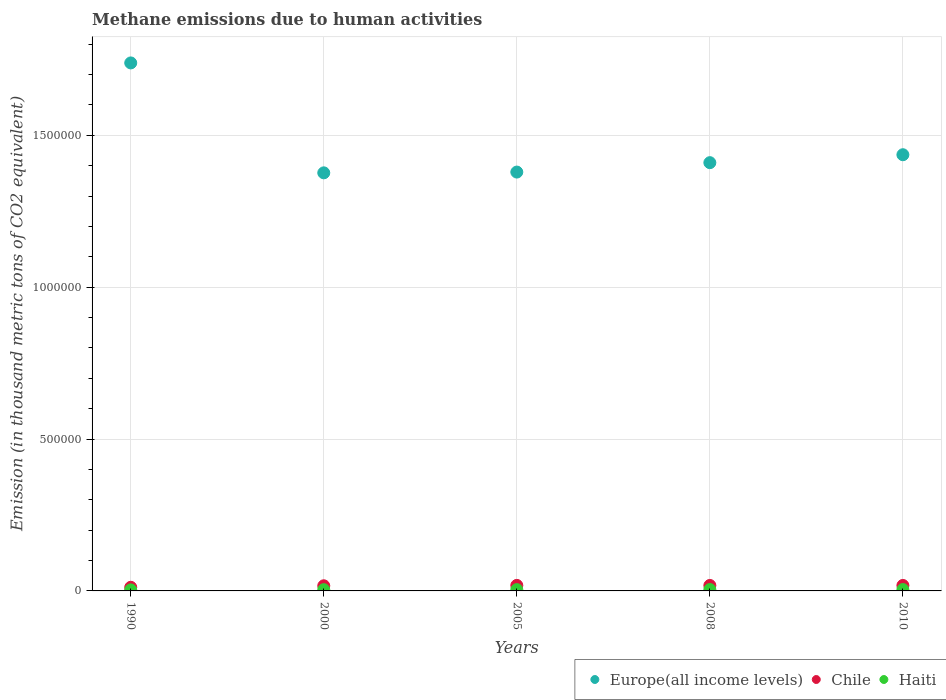Is the number of dotlines equal to the number of legend labels?
Your answer should be compact. Yes. What is the amount of methane emitted in Chile in 2010?
Give a very brief answer. 1.80e+04. Across all years, what is the maximum amount of methane emitted in Haiti?
Provide a short and direct response. 4497.3. Across all years, what is the minimum amount of methane emitted in Europe(all income levels)?
Provide a succinct answer. 1.38e+06. In which year was the amount of methane emitted in Europe(all income levels) minimum?
Provide a succinct answer. 2000. What is the total amount of methane emitted in Haiti in the graph?
Make the answer very short. 2.07e+04. What is the difference between the amount of methane emitted in Haiti in 2000 and that in 2005?
Give a very brief answer. -122.8. What is the difference between the amount of methane emitted in Haiti in 1990 and the amount of methane emitted in Chile in 2000?
Provide a succinct answer. -1.36e+04. What is the average amount of methane emitted in Chile per year?
Your response must be concise. 1.66e+04. In the year 2000, what is the difference between the amount of methane emitted in Chile and amount of methane emitted in Europe(all income levels)?
Offer a very short reply. -1.36e+06. What is the ratio of the amount of methane emitted in Haiti in 2008 to that in 2010?
Your answer should be very brief. 1. What is the difference between the highest and the second highest amount of methane emitted in Chile?
Offer a very short reply. 188.4. What is the difference between the highest and the lowest amount of methane emitted in Chile?
Your response must be concise. 6211.6. In how many years, is the amount of methane emitted in Chile greater than the average amount of methane emitted in Chile taken over all years?
Provide a succinct answer. 4. Is the sum of the amount of methane emitted in Europe(all income levels) in 1990 and 2010 greater than the maximum amount of methane emitted in Chile across all years?
Provide a succinct answer. Yes. Is it the case that in every year, the sum of the amount of methane emitted in Haiti and amount of methane emitted in Europe(all income levels)  is greater than the amount of methane emitted in Chile?
Keep it short and to the point. Yes. Is the amount of methane emitted in Chile strictly less than the amount of methane emitted in Europe(all income levels) over the years?
Your answer should be very brief. Yes. How many dotlines are there?
Keep it short and to the point. 3. What is the difference between two consecutive major ticks on the Y-axis?
Ensure brevity in your answer.  5.00e+05. Are the values on the major ticks of Y-axis written in scientific E-notation?
Make the answer very short. No. Does the graph contain any zero values?
Your answer should be very brief. No. Does the graph contain grids?
Provide a short and direct response. Yes. What is the title of the graph?
Ensure brevity in your answer.  Methane emissions due to human activities. Does "Somalia" appear as one of the legend labels in the graph?
Provide a succinct answer. No. What is the label or title of the Y-axis?
Offer a terse response. Emission (in thousand metric tons of CO2 equivalent). What is the Emission (in thousand metric tons of CO2 equivalent) of Europe(all income levels) in 1990?
Offer a terse response. 1.74e+06. What is the Emission (in thousand metric tons of CO2 equivalent) in Chile in 1990?
Offer a very short reply. 1.20e+04. What is the Emission (in thousand metric tons of CO2 equivalent) in Haiti in 1990?
Make the answer very short. 3307.8. What is the Emission (in thousand metric tons of CO2 equivalent) of Europe(all income levels) in 2000?
Your response must be concise. 1.38e+06. What is the Emission (in thousand metric tons of CO2 equivalent) of Chile in 2000?
Ensure brevity in your answer.  1.69e+04. What is the Emission (in thousand metric tons of CO2 equivalent) in Haiti in 2000?
Your answer should be very brief. 4132.6. What is the Emission (in thousand metric tons of CO2 equivalent) of Europe(all income levels) in 2005?
Make the answer very short. 1.38e+06. What is the Emission (in thousand metric tons of CO2 equivalent) of Chile in 2005?
Make the answer very short. 1.82e+04. What is the Emission (in thousand metric tons of CO2 equivalent) in Haiti in 2005?
Offer a very short reply. 4255.4. What is the Emission (in thousand metric tons of CO2 equivalent) of Europe(all income levels) in 2008?
Make the answer very short. 1.41e+06. What is the Emission (in thousand metric tons of CO2 equivalent) of Chile in 2008?
Offer a very short reply. 1.80e+04. What is the Emission (in thousand metric tons of CO2 equivalent) in Haiti in 2008?
Your response must be concise. 4492.1. What is the Emission (in thousand metric tons of CO2 equivalent) in Europe(all income levels) in 2010?
Ensure brevity in your answer.  1.44e+06. What is the Emission (in thousand metric tons of CO2 equivalent) in Chile in 2010?
Your answer should be compact. 1.80e+04. What is the Emission (in thousand metric tons of CO2 equivalent) of Haiti in 2010?
Offer a very short reply. 4497.3. Across all years, what is the maximum Emission (in thousand metric tons of CO2 equivalent) in Europe(all income levels)?
Keep it short and to the point. 1.74e+06. Across all years, what is the maximum Emission (in thousand metric tons of CO2 equivalent) of Chile?
Your response must be concise. 1.82e+04. Across all years, what is the maximum Emission (in thousand metric tons of CO2 equivalent) in Haiti?
Provide a short and direct response. 4497.3. Across all years, what is the minimum Emission (in thousand metric tons of CO2 equivalent) of Europe(all income levels)?
Give a very brief answer. 1.38e+06. Across all years, what is the minimum Emission (in thousand metric tons of CO2 equivalent) of Chile?
Offer a terse response. 1.20e+04. Across all years, what is the minimum Emission (in thousand metric tons of CO2 equivalent) in Haiti?
Ensure brevity in your answer.  3307.8. What is the total Emission (in thousand metric tons of CO2 equivalent) in Europe(all income levels) in the graph?
Your answer should be compact. 7.34e+06. What is the total Emission (in thousand metric tons of CO2 equivalent) in Chile in the graph?
Keep it short and to the point. 8.31e+04. What is the total Emission (in thousand metric tons of CO2 equivalent) of Haiti in the graph?
Your response must be concise. 2.07e+04. What is the difference between the Emission (in thousand metric tons of CO2 equivalent) in Europe(all income levels) in 1990 and that in 2000?
Offer a terse response. 3.62e+05. What is the difference between the Emission (in thousand metric tons of CO2 equivalent) of Chile in 1990 and that in 2000?
Keep it short and to the point. -4945.1. What is the difference between the Emission (in thousand metric tons of CO2 equivalent) of Haiti in 1990 and that in 2000?
Your response must be concise. -824.8. What is the difference between the Emission (in thousand metric tons of CO2 equivalent) of Europe(all income levels) in 1990 and that in 2005?
Provide a succinct answer. 3.59e+05. What is the difference between the Emission (in thousand metric tons of CO2 equivalent) of Chile in 1990 and that in 2005?
Your response must be concise. -6211.6. What is the difference between the Emission (in thousand metric tons of CO2 equivalent) in Haiti in 1990 and that in 2005?
Make the answer very short. -947.6. What is the difference between the Emission (in thousand metric tons of CO2 equivalent) of Europe(all income levels) in 1990 and that in 2008?
Your answer should be very brief. 3.28e+05. What is the difference between the Emission (in thousand metric tons of CO2 equivalent) in Chile in 1990 and that in 2008?
Keep it short and to the point. -6011.3. What is the difference between the Emission (in thousand metric tons of CO2 equivalent) in Haiti in 1990 and that in 2008?
Offer a terse response. -1184.3. What is the difference between the Emission (in thousand metric tons of CO2 equivalent) of Europe(all income levels) in 1990 and that in 2010?
Give a very brief answer. 3.02e+05. What is the difference between the Emission (in thousand metric tons of CO2 equivalent) in Chile in 1990 and that in 2010?
Your answer should be very brief. -6023.2. What is the difference between the Emission (in thousand metric tons of CO2 equivalent) in Haiti in 1990 and that in 2010?
Offer a very short reply. -1189.5. What is the difference between the Emission (in thousand metric tons of CO2 equivalent) in Europe(all income levels) in 2000 and that in 2005?
Offer a terse response. -2537.9. What is the difference between the Emission (in thousand metric tons of CO2 equivalent) of Chile in 2000 and that in 2005?
Your answer should be compact. -1266.5. What is the difference between the Emission (in thousand metric tons of CO2 equivalent) in Haiti in 2000 and that in 2005?
Your answer should be very brief. -122.8. What is the difference between the Emission (in thousand metric tons of CO2 equivalent) of Europe(all income levels) in 2000 and that in 2008?
Provide a succinct answer. -3.35e+04. What is the difference between the Emission (in thousand metric tons of CO2 equivalent) in Chile in 2000 and that in 2008?
Your answer should be compact. -1066.2. What is the difference between the Emission (in thousand metric tons of CO2 equivalent) of Haiti in 2000 and that in 2008?
Provide a short and direct response. -359.5. What is the difference between the Emission (in thousand metric tons of CO2 equivalent) of Europe(all income levels) in 2000 and that in 2010?
Offer a terse response. -5.96e+04. What is the difference between the Emission (in thousand metric tons of CO2 equivalent) in Chile in 2000 and that in 2010?
Offer a very short reply. -1078.1. What is the difference between the Emission (in thousand metric tons of CO2 equivalent) of Haiti in 2000 and that in 2010?
Your answer should be very brief. -364.7. What is the difference between the Emission (in thousand metric tons of CO2 equivalent) of Europe(all income levels) in 2005 and that in 2008?
Keep it short and to the point. -3.10e+04. What is the difference between the Emission (in thousand metric tons of CO2 equivalent) in Chile in 2005 and that in 2008?
Offer a very short reply. 200.3. What is the difference between the Emission (in thousand metric tons of CO2 equivalent) in Haiti in 2005 and that in 2008?
Your response must be concise. -236.7. What is the difference between the Emission (in thousand metric tons of CO2 equivalent) of Europe(all income levels) in 2005 and that in 2010?
Give a very brief answer. -5.71e+04. What is the difference between the Emission (in thousand metric tons of CO2 equivalent) in Chile in 2005 and that in 2010?
Offer a very short reply. 188.4. What is the difference between the Emission (in thousand metric tons of CO2 equivalent) in Haiti in 2005 and that in 2010?
Offer a very short reply. -241.9. What is the difference between the Emission (in thousand metric tons of CO2 equivalent) in Europe(all income levels) in 2008 and that in 2010?
Ensure brevity in your answer.  -2.61e+04. What is the difference between the Emission (in thousand metric tons of CO2 equivalent) in Haiti in 2008 and that in 2010?
Offer a very short reply. -5.2. What is the difference between the Emission (in thousand metric tons of CO2 equivalent) in Europe(all income levels) in 1990 and the Emission (in thousand metric tons of CO2 equivalent) in Chile in 2000?
Offer a very short reply. 1.72e+06. What is the difference between the Emission (in thousand metric tons of CO2 equivalent) of Europe(all income levels) in 1990 and the Emission (in thousand metric tons of CO2 equivalent) of Haiti in 2000?
Your answer should be very brief. 1.73e+06. What is the difference between the Emission (in thousand metric tons of CO2 equivalent) of Chile in 1990 and the Emission (in thousand metric tons of CO2 equivalent) of Haiti in 2000?
Your answer should be compact. 7845.5. What is the difference between the Emission (in thousand metric tons of CO2 equivalent) in Europe(all income levels) in 1990 and the Emission (in thousand metric tons of CO2 equivalent) in Chile in 2005?
Offer a terse response. 1.72e+06. What is the difference between the Emission (in thousand metric tons of CO2 equivalent) of Europe(all income levels) in 1990 and the Emission (in thousand metric tons of CO2 equivalent) of Haiti in 2005?
Offer a very short reply. 1.73e+06. What is the difference between the Emission (in thousand metric tons of CO2 equivalent) in Chile in 1990 and the Emission (in thousand metric tons of CO2 equivalent) in Haiti in 2005?
Make the answer very short. 7722.7. What is the difference between the Emission (in thousand metric tons of CO2 equivalent) in Europe(all income levels) in 1990 and the Emission (in thousand metric tons of CO2 equivalent) in Chile in 2008?
Offer a terse response. 1.72e+06. What is the difference between the Emission (in thousand metric tons of CO2 equivalent) in Europe(all income levels) in 1990 and the Emission (in thousand metric tons of CO2 equivalent) in Haiti in 2008?
Ensure brevity in your answer.  1.73e+06. What is the difference between the Emission (in thousand metric tons of CO2 equivalent) of Chile in 1990 and the Emission (in thousand metric tons of CO2 equivalent) of Haiti in 2008?
Offer a very short reply. 7486. What is the difference between the Emission (in thousand metric tons of CO2 equivalent) of Europe(all income levels) in 1990 and the Emission (in thousand metric tons of CO2 equivalent) of Chile in 2010?
Provide a succinct answer. 1.72e+06. What is the difference between the Emission (in thousand metric tons of CO2 equivalent) in Europe(all income levels) in 1990 and the Emission (in thousand metric tons of CO2 equivalent) in Haiti in 2010?
Your answer should be compact. 1.73e+06. What is the difference between the Emission (in thousand metric tons of CO2 equivalent) of Chile in 1990 and the Emission (in thousand metric tons of CO2 equivalent) of Haiti in 2010?
Keep it short and to the point. 7480.8. What is the difference between the Emission (in thousand metric tons of CO2 equivalent) of Europe(all income levels) in 2000 and the Emission (in thousand metric tons of CO2 equivalent) of Chile in 2005?
Your answer should be compact. 1.36e+06. What is the difference between the Emission (in thousand metric tons of CO2 equivalent) of Europe(all income levels) in 2000 and the Emission (in thousand metric tons of CO2 equivalent) of Haiti in 2005?
Make the answer very short. 1.37e+06. What is the difference between the Emission (in thousand metric tons of CO2 equivalent) of Chile in 2000 and the Emission (in thousand metric tons of CO2 equivalent) of Haiti in 2005?
Your response must be concise. 1.27e+04. What is the difference between the Emission (in thousand metric tons of CO2 equivalent) in Europe(all income levels) in 2000 and the Emission (in thousand metric tons of CO2 equivalent) in Chile in 2008?
Ensure brevity in your answer.  1.36e+06. What is the difference between the Emission (in thousand metric tons of CO2 equivalent) in Europe(all income levels) in 2000 and the Emission (in thousand metric tons of CO2 equivalent) in Haiti in 2008?
Offer a very short reply. 1.37e+06. What is the difference between the Emission (in thousand metric tons of CO2 equivalent) in Chile in 2000 and the Emission (in thousand metric tons of CO2 equivalent) in Haiti in 2008?
Offer a terse response. 1.24e+04. What is the difference between the Emission (in thousand metric tons of CO2 equivalent) in Europe(all income levels) in 2000 and the Emission (in thousand metric tons of CO2 equivalent) in Chile in 2010?
Give a very brief answer. 1.36e+06. What is the difference between the Emission (in thousand metric tons of CO2 equivalent) of Europe(all income levels) in 2000 and the Emission (in thousand metric tons of CO2 equivalent) of Haiti in 2010?
Give a very brief answer. 1.37e+06. What is the difference between the Emission (in thousand metric tons of CO2 equivalent) in Chile in 2000 and the Emission (in thousand metric tons of CO2 equivalent) in Haiti in 2010?
Your answer should be compact. 1.24e+04. What is the difference between the Emission (in thousand metric tons of CO2 equivalent) of Europe(all income levels) in 2005 and the Emission (in thousand metric tons of CO2 equivalent) of Chile in 2008?
Make the answer very short. 1.36e+06. What is the difference between the Emission (in thousand metric tons of CO2 equivalent) of Europe(all income levels) in 2005 and the Emission (in thousand metric tons of CO2 equivalent) of Haiti in 2008?
Provide a succinct answer. 1.37e+06. What is the difference between the Emission (in thousand metric tons of CO2 equivalent) of Chile in 2005 and the Emission (in thousand metric tons of CO2 equivalent) of Haiti in 2008?
Your answer should be compact. 1.37e+04. What is the difference between the Emission (in thousand metric tons of CO2 equivalent) of Europe(all income levels) in 2005 and the Emission (in thousand metric tons of CO2 equivalent) of Chile in 2010?
Your answer should be very brief. 1.36e+06. What is the difference between the Emission (in thousand metric tons of CO2 equivalent) in Europe(all income levels) in 2005 and the Emission (in thousand metric tons of CO2 equivalent) in Haiti in 2010?
Ensure brevity in your answer.  1.37e+06. What is the difference between the Emission (in thousand metric tons of CO2 equivalent) of Chile in 2005 and the Emission (in thousand metric tons of CO2 equivalent) of Haiti in 2010?
Offer a very short reply. 1.37e+04. What is the difference between the Emission (in thousand metric tons of CO2 equivalent) of Europe(all income levels) in 2008 and the Emission (in thousand metric tons of CO2 equivalent) of Chile in 2010?
Ensure brevity in your answer.  1.39e+06. What is the difference between the Emission (in thousand metric tons of CO2 equivalent) in Europe(all income levels) in 2008 and the Emission (in thousand metric tons of CO2 equivalent) in Haiti in 2010?
Your answer should be compact. 1.41e+06. What is the difference between the Emission (in thousand metric tons of CO2 equivalent) in Chile in 2008 and the Emission (in thousand metric tons of CO2 equivalent) in Haiti in 2010?
Offer a terse response. 1.35e+04. What is the average Emission (in thousand metric tons of CO2 equivalent) in Europe(all income levels) per year?
Provide a short and direct response. 1.47e+06. What is the average Emission (in thousand metric tons of CO2 equivalent) of Chile per year?
Make the answer very short. 1.66e+04. What is the average Emission (in thousand metric tons of CO2 equivalent) of Haiti per year?
Make the answer very short. 4137.04. In the year 1990, what is the difference between the Emission (in thousand metric tons of CO2 equivalent) in Europe(all income levels) and Emission (in thousand metric tons of CO2 equivalent) in Chile?
Provide a succinct answer. 1.73e+06. In the year 1990, what is the difference between the Emission (in thousand metric tons of CO2 equivalent) in Europe(all income levels) and Emission (in thousand metric tons of CO2 equivalent) in Haiti?
Offer a terse response. 1.74e+06. In the year 1990, what is the difference between the Emission (in thousand metric tons of CO2 equivalent) of Chile and Emission (in thousand metric tons of CO2 equivalent) of Haiti?
Keep it short and to the point. 8670.3. In the year 2000, what is the difference between the Emission (in thousand metric tons of CO2 equivalent) in Europe(all income levels) and Emission (in thousand metric tons of CO2 equivalent) in Chile?
Keep it short and to the point. 1.36e+06. In the year 2000, what is the difference between the Emission (in thousand metric tons of CO2 equivalent) of Europe(all income levels) and Emission (in thousand metric tons of CO2 equivalent) of Haiti?
Offer a very short reply. 1.37e+06. In the year 2000, what is the difference between the Emission (in thousand metric tons of CO2 equivalent) in Chile and Emission (in thousand metric tons of CO2 equivalent) in Haiti?
Make the answer very short. 1.28e+04. In the year 2005, what is the difference between the Emission (in thousand metric tons of CO2 equivalent) in Europe(all income levels) and Emission (in thousand metric tons of CO2 equivalent) in Chile?
Your answer should be compact. 1.36e+06. In the year 2005, what is the difference between the Emission (in thousand metric tons of CO2 equivalent) of Europe(all income levels) and Emission (in thousand metric tons of CO2 equivalent) of Haiti?
Ensure brevity in your answer.  1.37e+06. In the year 2005, what is the difference between the Emission (in thousand metric tons of CO2 equivalent) in Chile and Emission (in thousand metric tons of CO2 equivalent) in Haiti?
Keep it short and to the point. 1.39e+04. In the year 2008, what is the difference between the Emission (in thousand metric tons of CO2 equivalent) in Europe(all income levels) and Emission (in thousand metric tons of CO2 equivalent) in Chile?
Your response must be concise. 1.39e+06. In the year 2008, what is the difference between the Emission (in thousand metric tons of CO2 equivalent) in Europe(all income levels) and Emission (in thousand metric tons of CO2 equivalent) in Haiti?
Your answer should be compact. 1.41e+06. In the year 2008, what is the difference between the Emission (in thousand metric tons of CO2 equivalent) in Chile and Emission (in thousand metric tons of CO2 equivalent) in Haiti?
Offer a very short reply. 1.35e+04. In the year 2010, what is the difference between the Emission (in thousand metric tons of CO2 equivalent) in Europe(all income levels) and Emission (in thousand metric tons of CO2 equivalent) in Chile?
Ensure brevity in your answer.  1.42e+06. In the year 2010, what is the difference between the Emission (in thousand metric tons of CO2 equivalent) in Europe(all income levels) and Emission (in thousand metric tons of CO2 equivalent) in Haiti?
Your response must be concise. 1.43e+06. In the year 2010, what is the difference between the Emission (in thousand metric tons of CO2 equivalent) of Chile and Emission (in thousand metric tons of CO2 equivalent) of Haiti?
Make the answer very short. 1.35e+04. What is the ratio of the Emission (in thousand metric tons of CO2 equivalent) in Europe(all income levels) in 1990 to that in 2000?
Keep it short and to the point. 1.26. What is the ratio of the Emission (in thousand metric tons of CO2 equivalent) in Chile in 1990 to that in 2000?
Your answer should be compact. 0.71. What is the ratio of the Emission (in thousand metric tons of CO2 equivalent) in Haiti in 1990 to that in 2000?
Give a very brief answer. 0.8. What is the ratio of the Emission (in thousand metric tons of CO2 equivalent) of Europe(all income levels) in 1990 to that in 2005?
Give a very brief answer. 1.26. What is the ratio of the Emission (in thousand metric tons of CO2 equivalent) of Chile in 1990 to that in 2005?
Your response must be concise. 0.66. What is the ratio of the Emission (in thousand metric tons of CO2 equivalent) of Haiti in 1990 to that in 2005?
Keep it short and to the point. 0.78. What is the ratio of the Emission (in thousand metric tons of CO2 equivalent) of Europe(all income levels) in 1990 to that in 2008?
Give a very brief answer. 1.23. What is the ratio of the Emission (in thousand metric tons of CO2 equivalent) of Chile in 1990 to that in 2008?
Keep it short and to the point. 0.67. What is the ratio of the Emission (in thousand metric tons of CO2 equivalent) in Haiti in 1990 to that in 2008?
Provide a succinct answer. 0.74. What is the ratio of the Emission (in thousand metric tons of CO2 equivalent) in Europe(all income levels) in 1990 to that in 2010?
Give a very brief answer. 1.21. What is the ratio of the Emission (in thousand metric tons of CO2 equivalent) of Chile in 1990 to that in 2010?
Your answer should be compact. 0.67. What is the ratio of the Emission (in thousand metric tons of CO2 equivalent) in Haiti in 1990 to that in 2010?
Your answer should be compact. 0.74. What is the ratio of the Emission (in thousand metric tons of CO2 equivalent) of Europe(all income levels) in 2000 to that in 2005?
Make the answer very short. 1. What is the ratio of the Emission (in thousand metric tons of CO2 equivalent) of Chile in 2000 to that in 2005?
Ensure brevity in your answer.  0.93. What is the ratio of the Emission (in thousand metric tons of CO2 equivalent) in Haiti in 2000 to that in 2005?
Provide a succinct answer. 0.97. What is the ratio of the Emission (in thousand metric tons of CO2 equivalent) in Europe(all income levels) in 2000 to that in 2008?
Provide a short and direct response. 0.98. What is the ratio of the Emission (in thousand metric tons of CO2 equivalent) in Chile in 2000 to that in 2008?
Provide a succinct answer. 0.94. What is the ratio of the Emission (in thousand metric tons of CO2 equivalent) of Europe(all income levels) in 2000 to that in 2010?
Keep it short and to the point. 0.96. What is the ratio of the Emission (in thousand metric tons of CO2 equivalent) of Chile in 2000 to that in 2010?
Keep it short and to the point. 0.94. What is the ratio of the Emission (in thousand metric tons of CO2 equivalent) in Haiti in 2000 to that in 2010?
Keep it short and to the point. 0.92. What is the ratio of the Emission (in thousand metric tons of CO2 equivalent) of Europe(all income levels) in 2005 to that in 2008?
Offer a terse response. 0.98. What is the ratio of the Emission (in thousand metric tons of CO2 equivalent) of Chile in 2005 to that in 2008?
Provide a short and direct response. 1.01. What is the ratio of the Emission (in thousand metric tons of CO2 equivalent) in Haiti in 2005 to that in 2008?
Your response must be concise. 0.95. What is the ratio of the Emission (in thousand metric tons of CO2 equivalent) in Europe(all income levels) in 2005 to that in 2010?
Ensure brevity in your answer.  0.96. What is the ratio of the Emission (in thousand metric tons of CO2 equivalent) of Chile in 2005 to that in 2010?
Make the answer very short. 1.01. What is the ratio of the Emission (in thousand metric tons of CO2 equivalent) of Haiti in 2005 to that in 2010?
Keep it short and to the point. 0.95. What is the ratio of the Emission (in thousand metric tons of CO2 equivalent) in Europe(all income levels) in 2008 to that in 2010?
Keep it short and to the point. 0.98. What is the ratio of the Emission (in thousand metric tons of CO2 equivalent) in Haiti in 2008 to that in 2010?
Provide a succinct answer. 1. What is the difference between the highest and the second highest Emission (in thousand metric tons of CO2 equivalent) of Europe(all income levels)?
Offer a very short reply. 3.02e+05. What is the difference between the highest and the second highest Emission (in thousand metric tons of CO2 equivalent) in Chile?
Your response must be concise. 188.4. What is the difference between the highest and the lowest Emission (in thousand metric tons of CO2 equivalent) of Europe(all income levels)?
Give a very brief answer. 3.62e+05. What is the difference between the highest and the lowest Emission (in thousand metric tons of CO2 equivalent) in Chile?
Keep it short and to the point. 6211.6. What is the difference between the highest and the lowest Emission (in thousand metric tons of CO2 equivalent) in Haiti?
Your answer should be compact. 1189.5. 